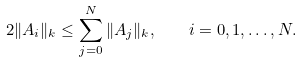Convert formula to latex. <formula><loc_0><loc_0><loc_500><loc_500>2 \| A _ { i } \| _ { k } \leq \sum _ { j = 0 } ^ { N } \| A _ { j } \| _ { k } , \quad i = 0 , 1 , \dots , N .</formula> 